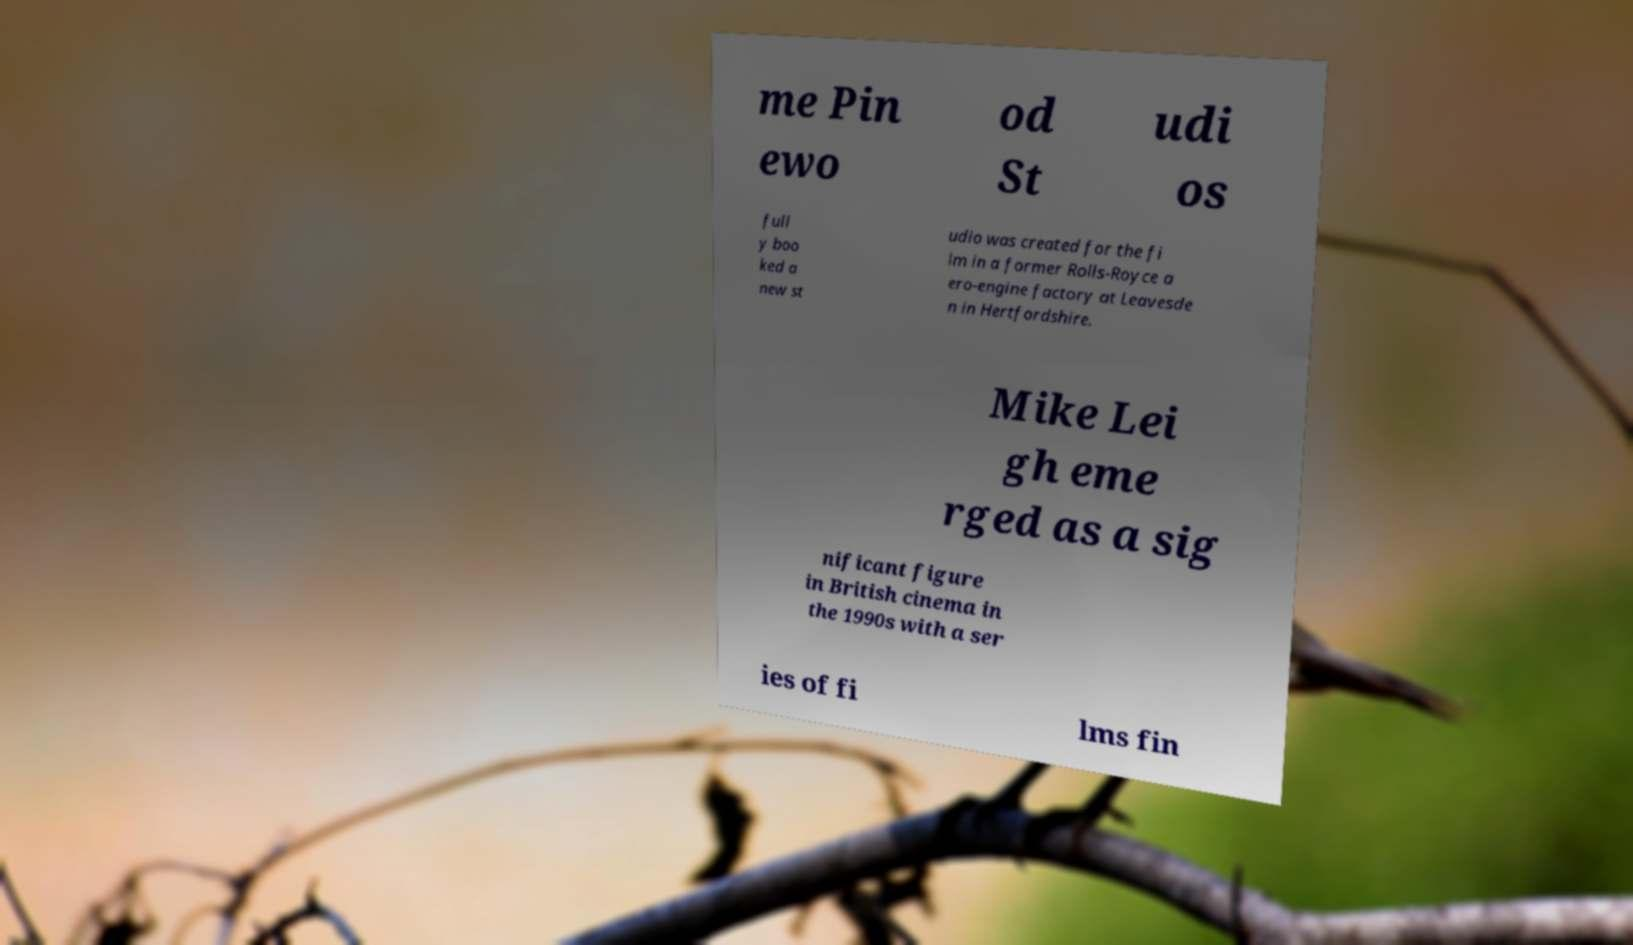Could you extract and type out the text from this image? me Pin ewo od St udi os full y boo ked a new st udio was created for the fi lm in a former Rolls-Royce a ero-engine factory at Leavesde n in Hertfordshire. Mike Lei gh eme rged as a sig nificant figure in British cinema in the 1990s with a ser ies of fi lms fin 